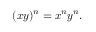<formula> <loc_0><loc_0><loc_500><loc_500>( x y ) ^ { n } = x ^ { n } y ^ { n } .</formula> 